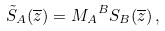<formula> <loc_0><loc_0><loc_500><loc_500>\tilde { S } _ { A } ( \overline { z } ) = { M _ { A } } ^ { B } S _ { B } ( \overline { z } ) \, ,</formula> 